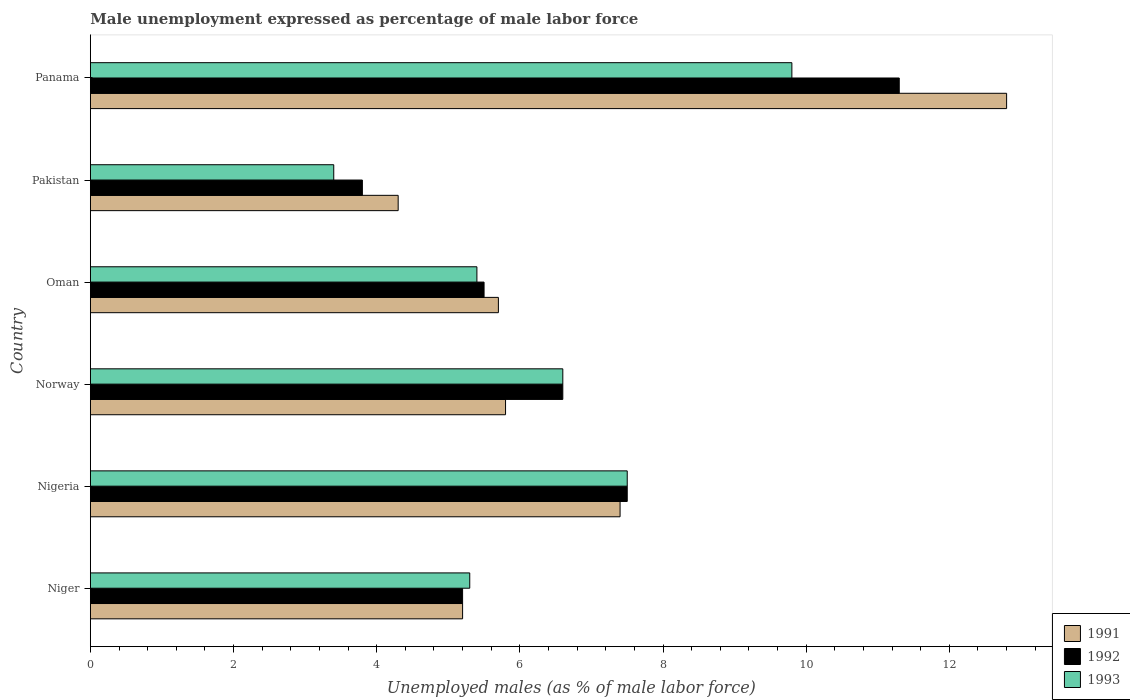How many groups of bars are there?
Offer a very short reply. 6. Are the number of bars per tick equal to the number of legend labels?
Keep it short and to the point. Yes. Are the number of bars on each tick of the Y-axis equal?
Provide a short and direct response. Yes. How many bars are there on the 1st tick from the bottom?
Provide a succinct answer. 3. What is the unemployment in males in in 1992 in Oman?
Provide a succinct answer. 5.5. Across all countries, what is the maximum unemployment in males in in 1992?
Your response must be concise. 11.3. Across all countries, what is the minimum unemployment in males in in 1993?
Ensure brevity in your answer.  3.4. In which country was the unemployment in males in in 1991 maximum?
Provide a succinct answer. Panama. In which country was the unemployment in males in in 1993 minimum?
Your answer should be very brief. Pakistan. What is the total unemployment in males in in 1992 in the graph?
Provide a succinct answer. 39.9. What is the difference between the unemployment in males in in 1991 in Niger and that in Pakistan?
Your response must be concise. 0.9. What is the difference between the unemployment in males in in 1993 in Pakistan and the unemployment in males in in 1992 in Norway?
Your response must be concise. -3.2. What is the average unemployment in males in in 1993 per country?
Ensure brevity in your answer.  6.33. What is the difference between the unemployment in males in in 1992 and unemployment in males in in 1993 in Pakistan?
Make the answer very short. 0.4. In how many countries, is the unemployment in males in in 1992 greater than 7.2 %?
Your answer should be compact. 2. What is the ratio of the unemployment in males in in 1993 in Oman to that in Pakistan?
Your answer should be very brief. 1.59. Is the unemployment in males in in 1992 in Nigeria less than that in Oman?
Your answer should be compact. No. What is the difference between the highest and the second highest unemployment in males in in 1991?
Provide a short and direct response. 5.4. What is the difference between the highest and the lowest unemployment in males in in 1993?
Your answer should be compact. 6.4. Is it the case that in every country, the sum of the unemployment in males in in 1993 and unemployment in males in in 1992 is greater than the unemployment in males in in 1991?
Provide a succinct answer. Yes. What is the difference between two consecutive major ticks on the X-axis?
Give a very brief answer. 2. Does the graph contain any zero values?
Give a very brief answer. No. Where does the legend appear in the graph?
Your response must be concise. Bottom right. How many legend labels are there?
Give a very brief answer. 3. What is the title of the graph?
Your answer should be very brief. Male unemployment expressed as percentage of male labor force. Does "1990" appear as one of the legend labels in the graph?
Your answer should be very brief. No. What is the label or title of the X-axis?
Offer a terse response. Unemployed males (as % of male labor force). What is the Unemployed males (as % of male labor force) in 1991 in Niger?
Your response must be concise. 5.2. What is the Unemployed males (as % of male labor force) of 1992 in Niger?
Provide a succinct answer. 5.2. What is the Unemployed males (as % of male labor force) in 1993 in Niger?
Provide a short and direct response. 5.3. What is the Unemployed males (as % of male labor force) in 1991 in Nigeria?
Make the answer very short. 7.4. What is the Unemployed males (as % of male labor force) in 1991 in Norway?
Provide a short and direct response. 5.8. What is the Unemployed males (as % of male labor force) in 1992 in Norway?
Ensure brevity in your answer.  6.6. What is the Unemployed males (as % of male labor force) of 1993 in Norway?
Give a very brief answer. 6.6. What is the Unemployed males (as % of male labor force) in 1991 in Oman?
Provide a short and direct response. 5.7. What is the Unemployed males (as % of male labor force) in 1992 in Oman?
Keep it short and to the point. 5.5. What is the Unemployed males (as % of male labor force) of 1993 in Oman?
Your response must be concise. 5.4. What is the Unemployed males (as % of male labor force) of 1991 in Pakistan?
Provide a succinct answer. 4.3. What is the Unemployed males (as % of male labor force) of 1992 in Pakistan?
Offer a terse response. 3.8. What is the Unemployed males (as % of male labor force) of 1993 in Pakistan?
Offer a very short reply. 3.4. What is the Unemployed males (as % of male labor force) of 1991 in Panama?
Give a very brief answer. 12.8. What is the Unemployed males (as % of male labor force) of 1992 in Panama?
Your response must be concise. 11.3. What is the Unemployed males (as % of male labor force) in 1993 in Panama?
Your response must be concise. 9.8. Across all countries, what is the maximum Unemployed males (as % of male labor force) in 1991?
Keep it short and to the point. 12.8. Across all countries, what is the maximum Unemployed males (as % of male labor force) in 1992?
Keep it short and to the point. 11.3. Across all countries, what is the maximum Unemployed males (as % of male labor force) in 1993?
Give a very brief answer. 9.8. Across all countries, what is the minimum Unemployed males (as % of male labor force) in 1991?
Ensure brevity in your answer.  4.3. Across all countries, what is the minimum Unemployed males (as % of male labor force) in 1992?
Your answer should be compact. 3.8. Across all countries, what is the minimum Unemployed males (as % of male labor force) in 1993?
Provide a short and direct response. 3.4. What is the total Unemployed males (as % of male labor force) in 1991 in the graph?
Give a very brief answer. 41.2. What is the total Unemployed males (as % of male labor force) of 1992 in the graph?
Offer a terse response. 39.9. What is the total Unemployed males (as % of male labor force) in 1993 in the graph?
Your answer should be very brief. 38. What is the difference between the Unemployed males (as % of male labor force) of 1992 in Niger and that in Nigeria?
Give a very brief answer. -2.3. What is the difference between the Unemployed males (as % of male labor force) of 1993 in Niger and that in Nigeria?
Ensure brevity in your answer.  -2.2. What is the difference between the Unemployed males (as % of male labor force) in 1993 in Niger and that in Norway?
Your answer should be compact. -1.3. What is the difference between the Unemployed males (as % of male labor force) in 1991 in Niger and that in Oman?
Offer a very short reply. -0.5. What is the difference between the Unemployed males (as % of male labor force) of 1992 in Niger and that in Oman?
Ensure brevity in your answer.  -0.3. What is the difference between the Unemployed males (as % of male labor force) of 1991 in Niger and that in Pakistan?
Your answer should be very brief. 0.9. What is the difference between the Unemployed males (as % of male labor force) in 1991 in Niger and that in Panama?
Offer a terse response. -7.6. What is the difference between the Unemployed males (as % of male labor force) of 1992 in Niger and that in Panama?
Give a very brief answer. -6.1. What is the difference between the Unemployed males (as % of male labor force) in 1991 in Nigeria and that in Norway?
Ensure brevity in your answer.  1.6. What is the difference between the Unemployed males (as % of male labor force) in 1992 in Nigeria and that in Norway?
Make the answer very short. 0.9. What is the difference between the Unemployed males (as % of male labor force) in 1993 in Nigeria and that in Oman?
Your answer should be compact. 2.1. What is the difference between the Unemployed males (as % of male labor force) of 1991 in Nigeria and that in Pakistan?
Ensure brevity in your answer.  3.1. What is the difference between the Unemployed males (as % of male labor force) of 1993 in Nigeria and that in Pakistan?
Your response must be concise. 4.1. What is the difference between the Unemployed males (as % of male labor force) in 1991 in Nigeria and that in Panama?
Your answer should be very brief. -5.4. What is the difference between the Unemployed males (as % of male labor force) in 1993 in Nigeria and that in Panama?
Offer a terse response. -2.3. What is the difference between the Unemployed males (as % of male labor force) of 1993 in Norway and that in Oman?
Ensure brevity in your answer.  1.2. What is the difference between the Unemployed males (as % of male labor force) in 1991 in Norway and that in Pakistan?
Your response must be concise. 1.5. What is the difference between the Unemployed males (as % of male labor force) in 1992 in Norway and that in Pakistan?
Your response must be concise. 2.8. What is the difference between the Unemployed males (as % of male labor force) in 1993 in Norway and that in Pakistan?
Offer a terse response. 3.2. What is the difference between the Unemployed males (as % of male labor force) in 1992 in Norway and that in Panama?
Your answer should be compact. -4.7. What is the difference between the Unemployed males (as % of male labor force) of 1993 in Norway and that in Panama?
Offer a terse response. -3.2. What is the difference between the Unemployed males (as % of male labor force) in 1992 in Oman and that in Pakistan?
Provide a succinct answer. 1.7. What is the difference between the Unemployed males (as % of male labor force) of 1993 in Oman and that in Pakistan?
Your answer should be very brief. 2. What is the difference between the Unemployed males (as % of male labor force) of 1991 in Pakistan and that in Panama?
Offer a very short reply. -8.5. What is the difference between the Unemployed males (as % of male labor force) of 1992 in Pakistan and that in Panama?
Offer a terse response. -7.5. What is the difference between the Unemployed males (as % of male labor force) in 1993 in Pakistan and that in Panama?
Your answer should be very brief. -6.4. What is the difference between the Unemployed males (as % of male labor force) of 1991 in Niger and the Unemployed males (as % of male labor force) of 1992 in Nigeria?
Your answer should be compact. -2.3. What is the difference between the Unemployed males (as % of male labor force) in 1992 in Niger and the Unemployed males (as % of male labor force) in 1993 in Nigeria?
Your answer should be very brief. -2.3. What is the difference between the Unemployed males (as % of male labor force) in 1991 in Niger and the Unemployed males (as % of male labor force) in 1993 in Norway?
Keep it short and to the point. -1.4. What is the difference between the Unemployed males (as % of male labor force) of 1991 in Niger and the Unemployed males (as % of male labor force) of 1992 in Oman?
Offer a very short reply. -0.3. What is the difference between the Unemployed males (as % of male labor force) of 1992 in Niger and the Unemployed males (as % of male labor force) of 1993 in Oman?
Your response must be concise. -0.2. What is the difference between the Unemployed males (as % of male labor force) of 1991 in Niger and the Unemployed males (as % of male labor force) of 1992 in Pakistan?
Ensure brevity in your answer.  1.4. What is the difference between the Unemployed males (as % of male labor force) of 1992 in Niger and the Unemployed males (as % of male labor force) of 1993 in Pakistan?
Give a very brief answer. 1.8. What is the difference between the Unemployed males (as % of male labor force) of 1992 in Niger and the Unemployed males (as % of male labor force) of 1993 in Panama?
Provide a short and direct response. -4.6. What is the difference between the Unemployed males (as % of male labor force) in 1991 in Nigeria and the Unemployed males (as % of male labor force) in 1993 in Norway?
Provide a succinct answer. 0.8. What is the difference between the Unemployed males (as % of male labor force) in 1992 in Nigeria and the Unemployed males (as % of male labor force) in 1993 in Norway?
Your answer should be compact. 0.9. What is the difference between the Unemployed males (as % of male labor force) in 1991 in Nigeria and the Unemployed males (as % of male labor force) in 1992 in Oman?
Give a very brief answer. 1.9. What is the difference between the Unemployed males (as % of male labor force) in 1991 in Nigeria and the Unemployed males (as % of male labor force) in 1992 in Pakistan?
Offer a terse response. 3.6. What is the difference between the Unemployed males (as % of male labor force) in 1992 in Nigeria and the Unemployed males (as % of male labor force) in 1993 in Pakistan?
Your answer should be compact. 4.1. What is the difference between the Unemployed males (as % of male labor force) of 1991 in Nigeria and the Unemployed males (as % of male labor force) of 1992 in Panama?
Offer a terse response. -3.9. What is the difference between the Unemployed males (as % of male labor force) of 1991 in Norway and the Unemployed males (as % of male labor force) of 1992 in Oman?
Offer a very short reply. 0.3. What is the difference between the Unemployed males (as % of male labor force) of 1992 in Norway and the Unemployed males (as % of male labor force) of 1993 in Pakistan?
Keep it short and to the point. 3.2. What is the difference between the Unemployed males (as % of male labor force) of 1991 in Norway and the Unemployed males (as % of male labor force) of 1993 in Panama?
Give a very brief answer. -4. What is the difference between the Unemployed males (as % of male labor force) in 1992 in Norway and the Unemployed males (as % of male labor force) in 1993 in Panama?
Provide a short and direct response. -3.2. What is the difference between the Unemployed males (as % of male labor force) of 1991 in Oman and the Unemployed males (as % of male labor force) of 1993 in Pakistan?
Ensure brevity in your answer.  2.3. What is the difference between the Unemployed males (as % of male labor force) of 1991 in Oman and the Unemployed males (as % of male labor force) of 1993 in Panama?
Offer a terse response. -4.1. What is the difference between the Unemployed males (as % of male labor force) in 1991 in Pakistan and the Unemployed males (as % of male labor force) in 1992 in Panama?
Your response must be concise. -7. What is the difference between the Unemployed males (as % of male labor force) of 1992 in Pakistan and the Unemployed males (as % of male labor force) of 1993 in Panama?
Provide a succinct answer. -6. What is the average Unemployed males (as % of male labor force) of 1991 per country?
Offer a very short reply. 6.87. What is the average Unemployed males (as % of male labor force) in 1992 per country?
Make the answer very short. 6.65. What is the average Unemployed males (as % of male labor force) of 1993 per country?
Your answer should be compact. 6.33. What is the difference between the Unemployed males (as % of male labor force) of 1991 and Unemployed males (as % of male labor force) of 1992 in Niger?
Offer a very short reply. 0. What is the difference between the Unemployed males (as % of male labor force) in 1991 and Unemployed males (as % of male labor force) in 1993 in Niger?
Provide a succinct answer. -0.1. What is the difference between the Unemployed males (as % of male labor force) of 1992 and Unemployed males (as % of male labor force) of 1993 in Niger?
Offer a terse response. -0.1. What is the difference between the Unemployed males (as % of male labor force) in 1991 and Unemployed males (as % of male labor force) in 1992 in Nigeria?
Your response must be concise. -0.1. What is the difference between the Unemployed males (as % of male labor force) in 1992 and Unemployed males (as % of male labor force) in 1993 in Nigeria?
Your answer should be compact. 0. What is the difference between the Unemployed males (as % of male labor force) of 1991 and Unemployed males (as % of male labor force) of 1993 in Norway?
Provide a short and direct response. -0.8. What is the difference between the Unemployed males (as % of male labor force) of 1991 and Unemployed males (as % of male labor force) of 1992 in Oman?
Provide a short and direct response. 0.2. What is the difference between the Unemployed males (as % of male labor force) in 1992 and Unemployed males (as % of male labor force) in 1993 in Oman?
Your answer should be compact. 0.1. What is the difference between the Unemployed males (as % of male labor force) of 1991 and Unemployed males (as % of male labor force) of 1992 in Pakistan?
Your response must be concise. 0.5. What is the difference between the Unemployed males (as % of male labor force) of 1991 and Unemployed males (as % of male labor force) of 1993 in Pakistan?
Your response must be concise. 0.9. What is the difference between the Unemployed males (as % of male labor force) in 1992 and Unemployed males (as % of male labor force) in 1993 in Pakistan?
Your answer should be very brief. 0.4. What is the difference between the Unemployed males (as % of male labor force) in 1991 and Unemployed males (as % of male labor force) in 1993 in Panama?
Offer a terse response. 3. What is the ratio of the Unemployed males (as % of male labor force) in 1991 in Niger to that in Nigeria?
Keep it short and to the point. 0.7. What is the ratio of the Unemployed males (as % of male labor force) in 1992 in Niger to that in Nigeria?
Offer a very short reply. 0.69. What is the ratio of the Unemployed males (as % of male labor force) of 1993 in Niger to that in Nigeria?
Your answer should be compact. 0.71. What is the ratio of the Unemployed males (as % of male labor force) of 1991 in Niger to that in Norway?
Your response must be concise. 0.9. What is the ratio of the Unemployed males (as % of male labor force) of 1992 in Niger to that in Norway?
Your answer should be compact. 0.79. What is the ratio of the Unemployed males (as % of male labor force) of 1993 in Niger to that in Norway?
Ensure brevity in your answer.  0.8. What is the ratio of the Unemployed males (as % of male labor force) in 1991 in Niger to that in Oman?
Provide a short and direct response. 0.91. What is the ratio of the Unemployed males (as % of male labor force) in 1992 in Niger to that in Oman?
Offer a very short reply. 0.95. What is the ratio of the Unemployed males (as % of male labor force) in 1993 in Niger to that in Oman?
Offer a very short reply. 0.98. What is the ratio of the Unemployed males (as % of male labor force) of 1991 in Niger to that in Pakistan?
Offer a terse response. 1.21. What is the ratio of the Unemployed males (as % of male labor force) in 1992 in Niger to that in Pakistan?
Provide a short and direct response. 1.37. What is the ratio of the Unemployed males (as % of male labor force) of 1993 in Niger to that in Pakistan?
Offer a terse response. 1.56. What is the ratio of the Unemployed males (as % of male labor force) in 1991 in Niger to that in Panama?
Your answer should be compact. 0.41. What is the ratio of the Unemployed males (as % of male labor force) in 1992 in Niger to that in Panama?
Ensure brevity in your answer.  0.46. What is the ratio of the Unemployed males (as % of male labor force) in 1993 in Niger to that in Panama?
Offer a very short reply. 0.54. What is the ratio of the Unemployed males (as % of male labor force) in 1991 in Nigeria to that in Norway?
Provide a short and direct response. 1.28. What is the ratio of the Unemployed males (as % of male labor force) in 1992 in Nigeria to that in Norway?
Offer a terse response. 1.14. What is the ratio of the Unemployed males (as % of male labor force) of 1993 in Nigeria to that in Norway?
Your response must be concise. 1.14. What is the ratio of the Unemployed males (as % of male labor force) in 1991 in Nigeria to that in Oman?
Your response must be concise. 1.3. What is the ratio of the Unemployed males (as % of male labor force) in 1992 in Nigeria to that in Oman?
Provide a short and direct response. 1.36. What is the ratio of the Unemployed males (as % of male labor force) of 1993 in Nigeria to that in Oman?
Offer a very short reply. 1.39. What is the ratio of the Unemployed males (as % of male labor force) in 1991 in Nigeria to that in Pakistan?
Your response must be concise. 1.72. What is the ratio of the Unemployed males (as % of male labor force) in 1992 in Nigeria to that in Pakistan?
Offer a terse response. 1.97. What is the ratio of the Unemployed males (as % of male labor force) of 1993 in Nigeria to that in Pakistan?
Make the answer very short. 2.21. What is the ratio of the Unemployed males (as % of male labor force) in 1991 in Nigeria to that in Panama?
Provide a short and direct response. 0.58. What is the ratio of the Unemployed males (as % of male labor force) of 1992 in Nigeria to that in Panama?
Give a very brief answer. 0.66. What is the ratio of the Unemployed males (as % of male labor force) of 1993 in Nigeria to that in Panama?
Keep it short and to the point. 0.77. What is the ratio of the Unemployed males (as % of male labor force) in 1991 in Norway to that in Oman?
Offer a terse response. 1.02. What is the ratio of the Unemployed males (as % of male labor force) of 1992 in Norway to that in Oman?
Offer a very short reply. 1.2. What is the ratio of the Unemployed males (as % of male labor force) of 1993 in Norway to that in Oman?
Ensure brevity in your answer.  1.22. What is the ratio of the Unemployed males (as % of male labor force) of 1991 in Norway to that in Pakistan?
Keep it short and to the point. 1.35. What is the ratio of the Unemployed males (as % of male labor force) of 1992 in Norway to that in Pakistan?
Your answer should be compact. 1.74. What is the ratio of the Unemployed males (as % of male labor force) in 1993 in Norway to that in Pakistan?
Make the answer very short. 1.94. What is the ratio of the Unemployed males (as % of male labor force) in 1991 in Norway to that in Panama?
Make the answer very short. 0.45. What is the ratio of the Unemployed males (as % of male labor force) of 1992 in Norway to that in Panama?
Your response must be concise. 0.58. What is the ratio of the Unemployed males (as % of male labor force) in 1993 in Norway to that in Panama?
Your answer should be compact. 0.67. What is the ratio of the Unemployed males (as % of male labor force) in 1991 in Oman to that in Pakistan?
Ensure brevity in your answer.  1.33. What is the ratio of the Unemployed males (as % of male labor force) in 1992 in Oman to that in Pakistan?
Provide a succinct answer. 1.45. What is the ratio of the Unemployed males (as % of male labor force) in 1993 in Oman to that in Pakistan?
Provide a short and direct response. 1.59. What is the ratio of the Unemployed males (as % of male labor force) in 1991 in Oman to that in Panama?
Your answer should be very brief. 0.45. What is the ratio of the Unemployed males (as % of male labor force) in 1992 in Oman to that in Panama?
Make the answer very short. 0.49. What is the ratio of the Unemployed males (as % of male labor force) of 1993 in Oman to that in Panama?
Provide a short and direct response. 0.55. What is the ratio of the Unemployed males (as % of male labor force) in 1991 in Pakistan to that in Panama?
Provide a succinct answer. 0.34. What is the ratio of the Unemployed males (as % of male labor force) in 1992 in Pakistan to that in Panama?
Your answer should be compact. 0.34. What is the ratio of the Unemployed males (as % of male labor force) of 1993 in Pakistan to that in Panama?
Make the answer very short. 0.35. What is the difference between the highest and the lowest Unemployed males (as % of male labor force) of 1991?
Give a very brief answer. 8.5. What is the difference between the highest and the lowest Unemployed males (as % of male labor force) of 1992?
Provide a short and direct response. 7.5. 